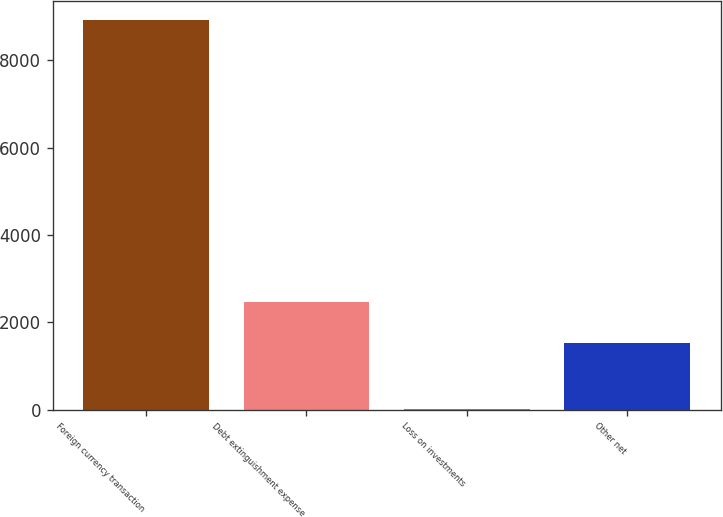Convert chart. <chart><loc_0><loc_0><loc_500><loc_500><bar_chart><fcel>Foreign currency transaction<fcel>Debt extinguishment expense<fcel>Loss on investments<fcel>Other net<nl><fcel>8915<fcel>2454<fcel>3.72<fcel>1527<nl></chart> 